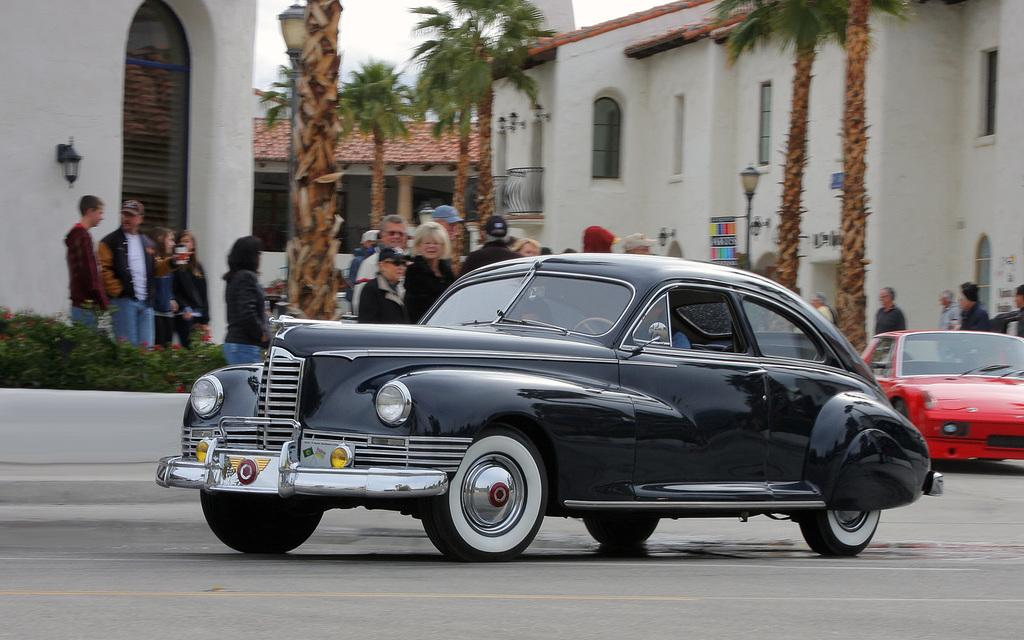What can be seen on the road in the image? There are cars on the road in the image. What else is present in the image besides the cars? There is a group of people, plants, trees, buildings, and some objects in the image. Can you describe the vegetation in the image? Plants and trees are visible in the image. What is visible in the background of the image? The sky is visible in the background of the image. What type of discovery was made at the plantation in the image? There is no mention of a plantation or plantation in the image; it features cars on the road, a group of people, plants, trees, buildings, and objects. How many cows are visible in the image? There are no cows present in the image. 